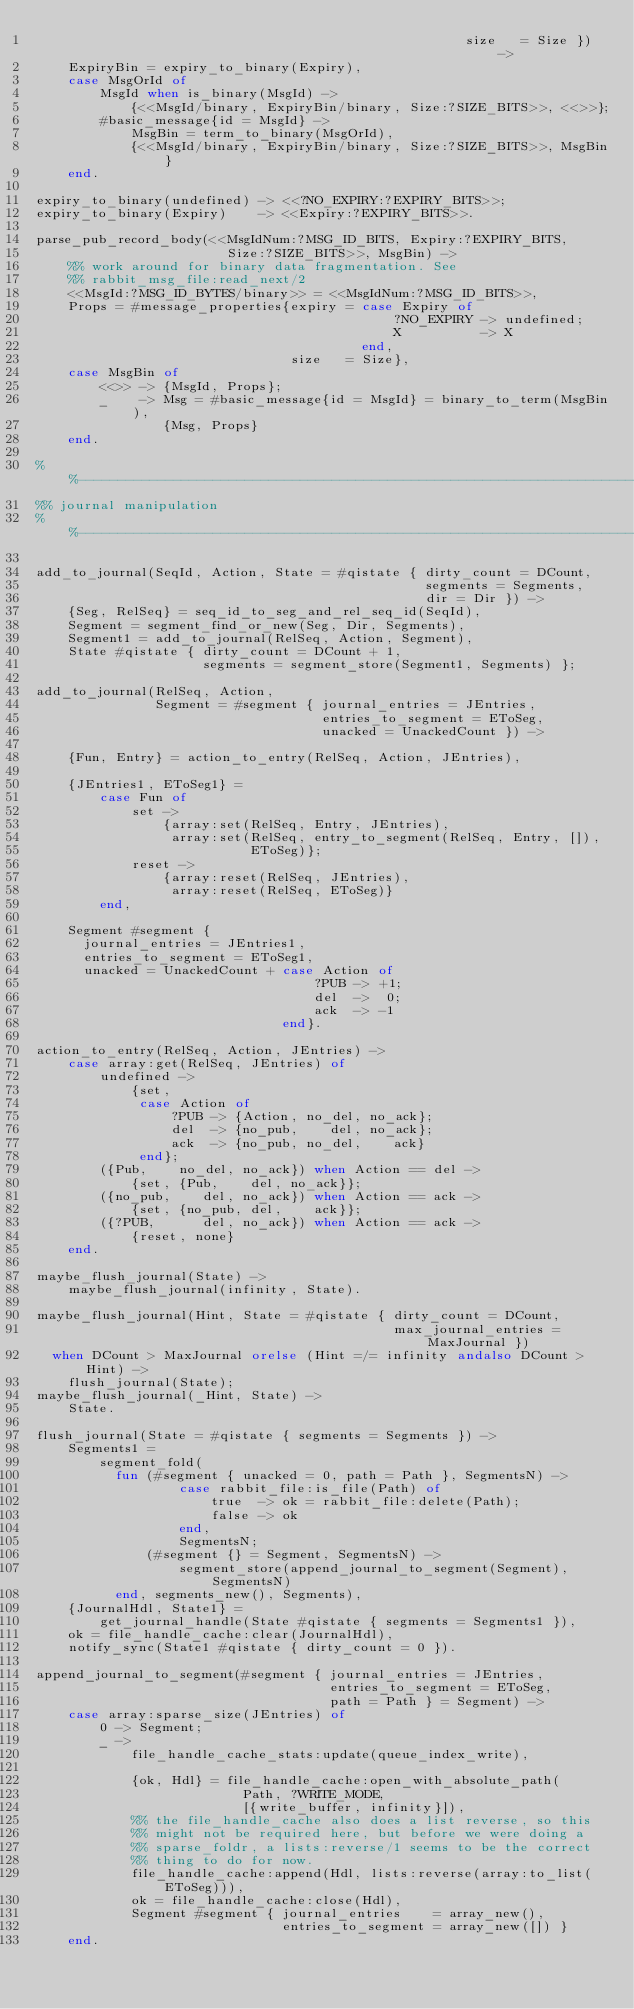<code> <loc_0><loc_0><loc_500><loc_500><_Erlang_>                                                      size   = Size }) ->
    ExpiryBin = expiry_to_binary(Expiry),
    case MsgOrId of
        MsgId when is_binary(MsgId) ->
            {<<MsgId/binary, ExpiryBin/binary, Size:?SIZE_BITS>>, <<>>};
        #basic_message{id = MsgId} ->
            MsgBin = term_to_binary(MsgOrId),
            {<<MsgId/binary, ExpiryBin/binary, Size:?SIZE_BITS>>, MsgBin}
    end.

expiry_to_binary(undefined) -> <<?NO_EXPIRY:?EXPIRY_BITS>>;
expiry_to_binary(Expiry)    -> <<Expiry:?EXPIRY_BITS>>.

parse_pub_record_body(<<MsgIdNum:?MSG_ID_BITS, Expiry:?EXPIRY_BITS,
                        Size:?SIZE_BITS>>, MsgBin) ->
    %% work around for binary data fragmentation. See
    %% rabbit_msg_file:read_next/2
    <<MsgId:?MSG_ID_BYTES/binary>> = <<MsgIdNum:?MSG_ID_BITS>>,
    Props = #message_properties{expiry = case Expiry of
                                             ?NO_EXPIRY -> undefined;
                                             X          -> X
                                         end,
                                size   = Size},
    case MsgBin of
        <<>> -> {MsgId, Props};
        _    -> Msg = #basic_message{id = MsgId} = binary_to_term(MsgBin),
                {Msg, Props}
    end.

%%----------------------------------------------------------------------------
%% journal manipulation
%%----------------------------------------------------------------------------

add_to_journal(SeqId, Action, State = #qistate { dirty_count = DCount,
                                                 segments = Segments,
                                                 dir = Dir }) ->
    {Seg, RelSeq} = seq_id_to_seg_and_rel_seq_id(SeqId),
    Segment = segment_find_or_new(Seg, Dir, Segments),
    Segment1 = add_to_journal(RelSeq, Action, Segment),
    State #qistate { dirty_count = DCount + 1,
                     segments = segment_store(Segment1, Segments) };

add_to_journal(RelSeq, Action,
               Segment = #segment { journal_entries = JEntries,
                                    entries_to_segment = EToSeg,
                                    unacked = UnackedCount }) ->

    {Fun, Entry} = action_to_entry(RelSeq, Action, JEntries),

    {JEntries1, EToSeg1} =
        case Fun of
            set ->
                {array:set(RelSeq, Entry, JEntries),
                 array:set(RelSeq, entry_to_segment(RelSeq, Entry, []),
                           EToSeg)};
            reset ->
                {array:reset(RelSeq, JEntries),
                 array:reset(RelSeq, EToSeg)}
        end,

    Segment #segment {
      journal_entries = JEntries1,
      entries_to_segment = EToSeg1,
      unacked = UnackedCount + case Action of
                                   ?PUB -> +1;
                                   del  ->  0;
                                   ack  -> -1
                               end}.

action_to_entry(RelSeq, Action, JEntries) ->
    case array:get(RelSeq, JEntries) of
        undefined ->
            {set,
             case Action of
                 ?PUB -> {Action, no_del, no_ack};
                 del  -> {no_pub,    del, no_ack};
                 ack  -> {no_pub, no_del,    ack}
             end};
        ({Pub,    no_del, no_ack}) when Action == del ->
            {set, {Pub,    del, no_ack}};
        ({no_pub,    del, no_ack}) when Action == ack ->
            {set, {no_pub, del,    ack}};
        ({?PUB,      del, no_ack}) when Action == ack ->
            {reset, none}
    end.

maybe_flush_journal(State) ->
    maybe_flush_journal(infinity, State).

maybe_flush_journal(Hint, State = #qistate { dirty_count = DCount,
                                             max_journal_entries = MaxJournal })
  when DCount > MaxJournal orelse (Hint =/= infinity andalso DCount > Hint) ->
    flush_journal(State);
maybe_flush_journal(_Hint, State) ->
    State.

flush_journal(State = #qistate { segments = Segments }) ->
    Segments1 =
        segment_fold(
          fun (#segment { unacked = 0, path = Path }, SegmentsN) ->
                  case rabbit_file:is_file(Path) of
                      true  -> ok = rabbit_file:delete(Path);
                      false -> ok
                  end,
                  SegmentsN;
              (#segment {} = Segment, SegmentsN) ->
                  segment_store(append_journal_to_segment(Segment), SegmentsN)
          end, segments_new(), Segments),
    {JournalHdl, State1} =
        get_journal_handle(State #qistate { segments = Segments1 }),
    ok = file_handle_cache:clear(JournalHdl),
    notify_sync(State1 #qistate { dirty_count = 0 }).

append_journal_to_segment(#segment { journal_entries = JEntries,
                                     entries_to_segment = EToSeg,
                                     path = Path } = Segment) ->
    case array:sparse_size(JEntries) of
        0 -> Segment;
        _ ->
            file_handle_cache_stats:update(queue_index_write),

            {ok, Hdl} = file_handle_cache:open_with_absolute_path(
                          Path, ?WRITE_MODE,
                          [{write_buffer, infinity}]),
            %% the file_handle_cache also does a list reverse, so this
            %% might not be required here, but before we were doing a
            %% sparse_foldr, a lists:reverse/1 seems to be the correct
            %% thing to do for now.
            file_handle_cache:append(Hdl, lists:reverse(array:to_list(EToSeg))),
            ok = file_handle_cache:close(Hdl),
            Segment #segment { journal_entries    = array_new(),
                               entries_to_segment = array_new([]) }
    end.
</code> 